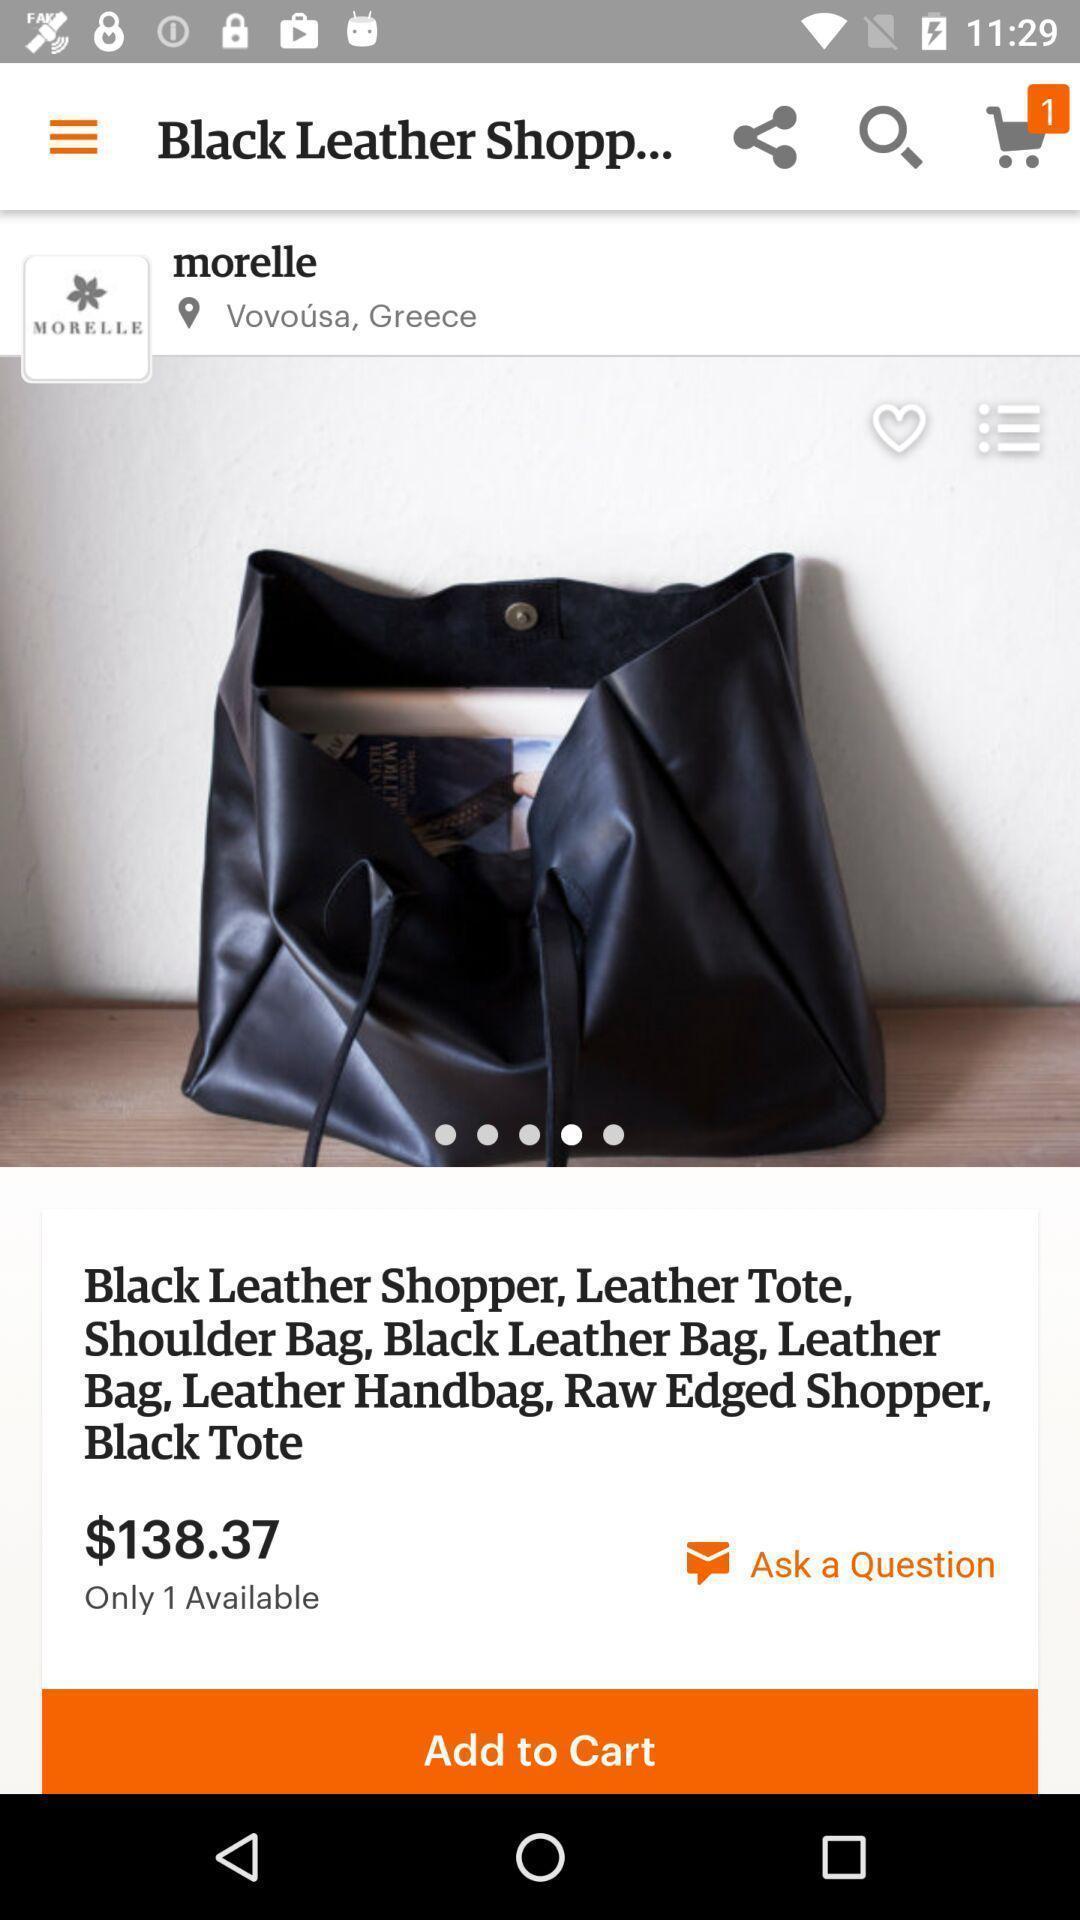Explain what's happening in this screen capture. Page showing details of a bag on a shopping app. 